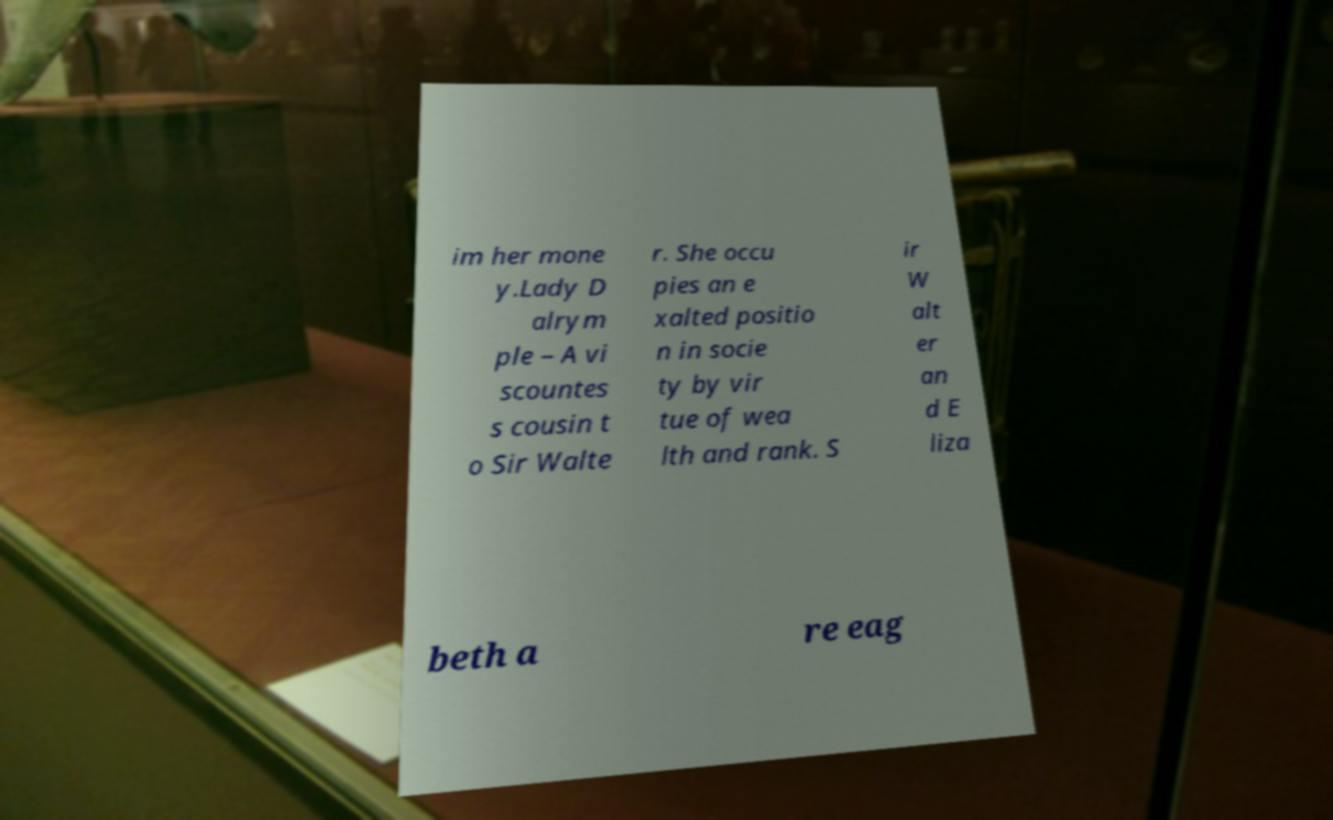Could you extract and type out the text from this image? im her mone y.Lady D alrym ple – A vi scountes s cousin t o Sir Walte r. She occu pies an e xalted positio n in socie ty by vir tue of wea lth and rank. S ir W alt er an d E liza beth a re eag 